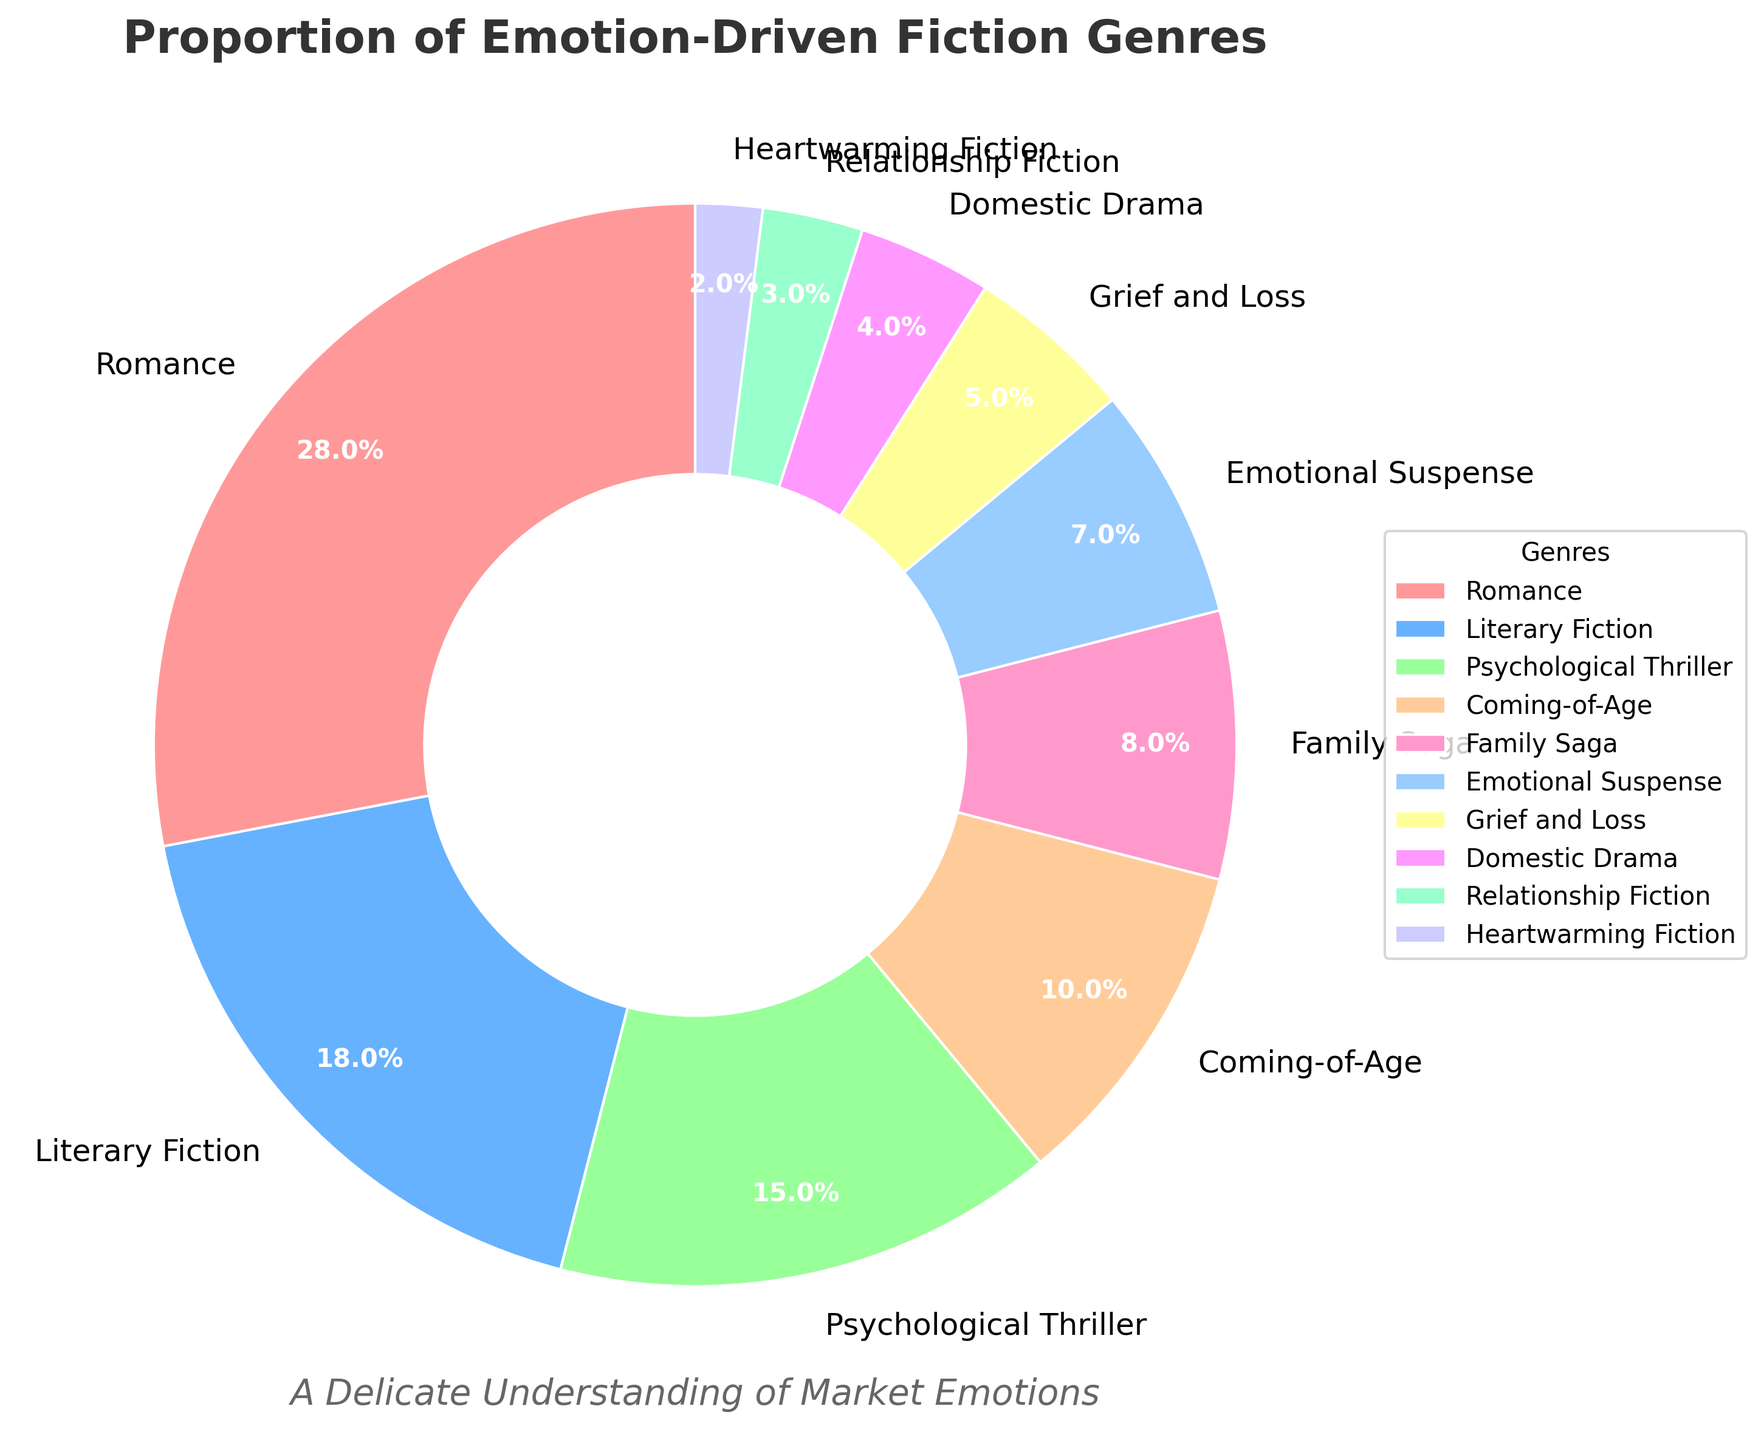What is the most represented genre in the fiction market according to the chart? The chart shows the percentage each genre occupies in the fiction market. By inspecting the sizes of the wedges and their associated labels, we see that Romance has the largest wedge, indicating it is the most represented genre.
Answer: Romance Which genre occupies the smallest proportion of the fiction market? By examining the chart, we find the smallest wedge and its corresponding label. The wedge labeled "Heartwarming Fiction" is the smallest, representing the smallest proportion of the fiction market.
Answer: Heartwarming Fiction How much larger is the percentage of Romance compared to Literary Fiction? First, we find the percentages for Romance (28%) and Literary Fiction (18%) from the chart. Subtract the percentage of Literary Fiction from Romance: 28% - 18% = 10%.
Answer: 10% What is the combined proportion of Psychological Thriller and Emotional Suspense genres? From the chart, Psychological Thriller is 15% and Emotional Suspense is 7%. Summing these percentages: 15% + 7% = 22%.
Answer: 22% Which genre has a larger market share, Coming-of-Age or Family Saga, and by how much? The chart shows that Coming-of-Age is 10% and Family Saga is 8%. The difference between the two is 10% - 8% = 2%. Therefore, Coming-of-Age is larger by 2%.
Answer: Coming-of-Age by 2% What are the total percentages of genres classified under emotional themes like Grief and Loss and Domestic Drama? Looking at the chart, Grief and Loss is 5% and Domestic Drama is 4%. Summing these percentages: 5% + 4% = 9%.
Answer: 9% What is the average market proportion of the three least represented genres? The least represented genres are Heartwarming Fiction (2%), Relationship Fiction (3%), and Domestic Drama (4%). To find the average: (2% + 3% + 4%) / 3 = 9% / 3 = 3%.
Answer: 3% Do Romance and Literary Fiction together account for more than 40% of the market? Summing their percentages from the chart: Romance (28%) + Literary Fiction (18%) = 46%. Since 46% is greater than 40%, they do account for more than 40% of the market.
Answer: Yes Which has a greater proportion, Emotional Suspense or the combined total of Grief and Loss and Heartwarming Fiction? Emotional Suspense is 7%, and the combined total of Grief and Loss (5%) and Heartwarming Fiction (2%) is 5% + 2% = 7%. They are equal.
Answer: They are equal 